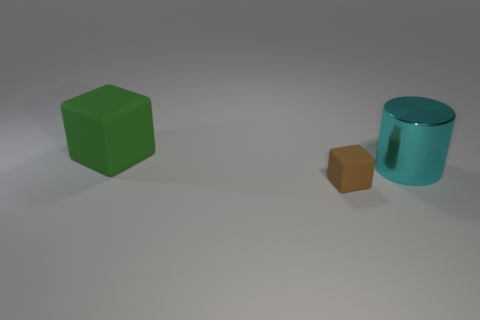Add 3 cyan shiny cylinders. How many objects exist? 6 Subtract all cylinders. How many objects are left? 2 Add 3 cyan objects. How many cyan objects are left? 4 Add 1 green metal things. How many green metal things exist? 1 Subtract 0 cyan balls. How many objects are left? 3 Subtract all purple balls. Subtract all cyan metallic objects. How many objects are left? 2 